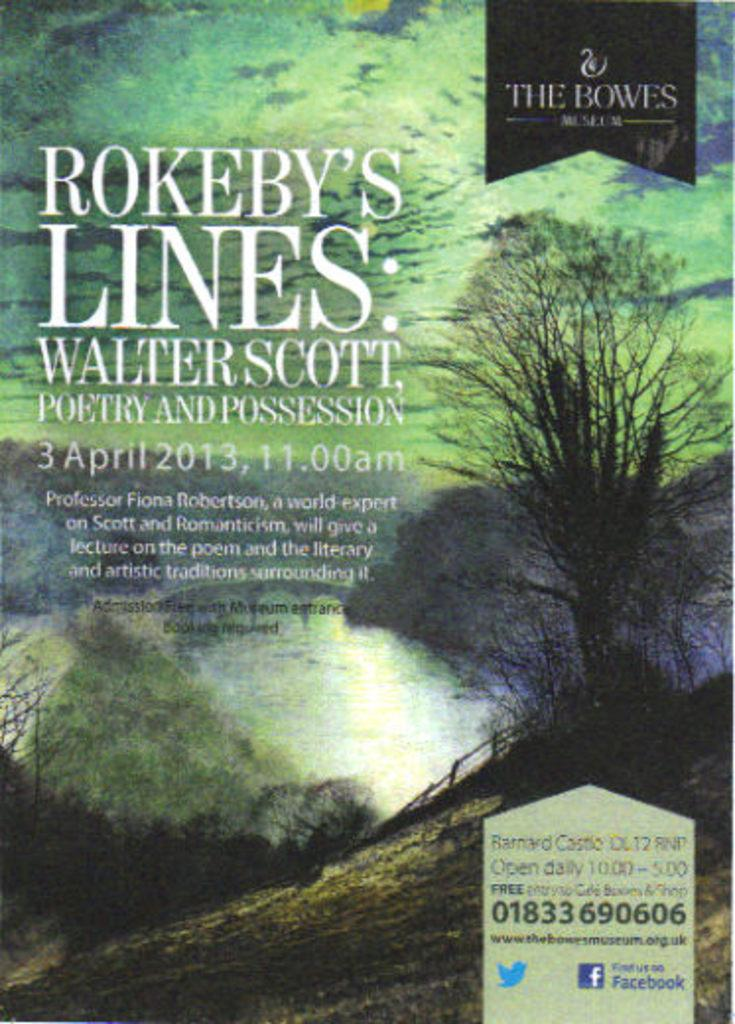<image>
Give a short and clear explanation of the subsequent image. a copy of the book titled Rokeby's Lines: Walter Scott. 